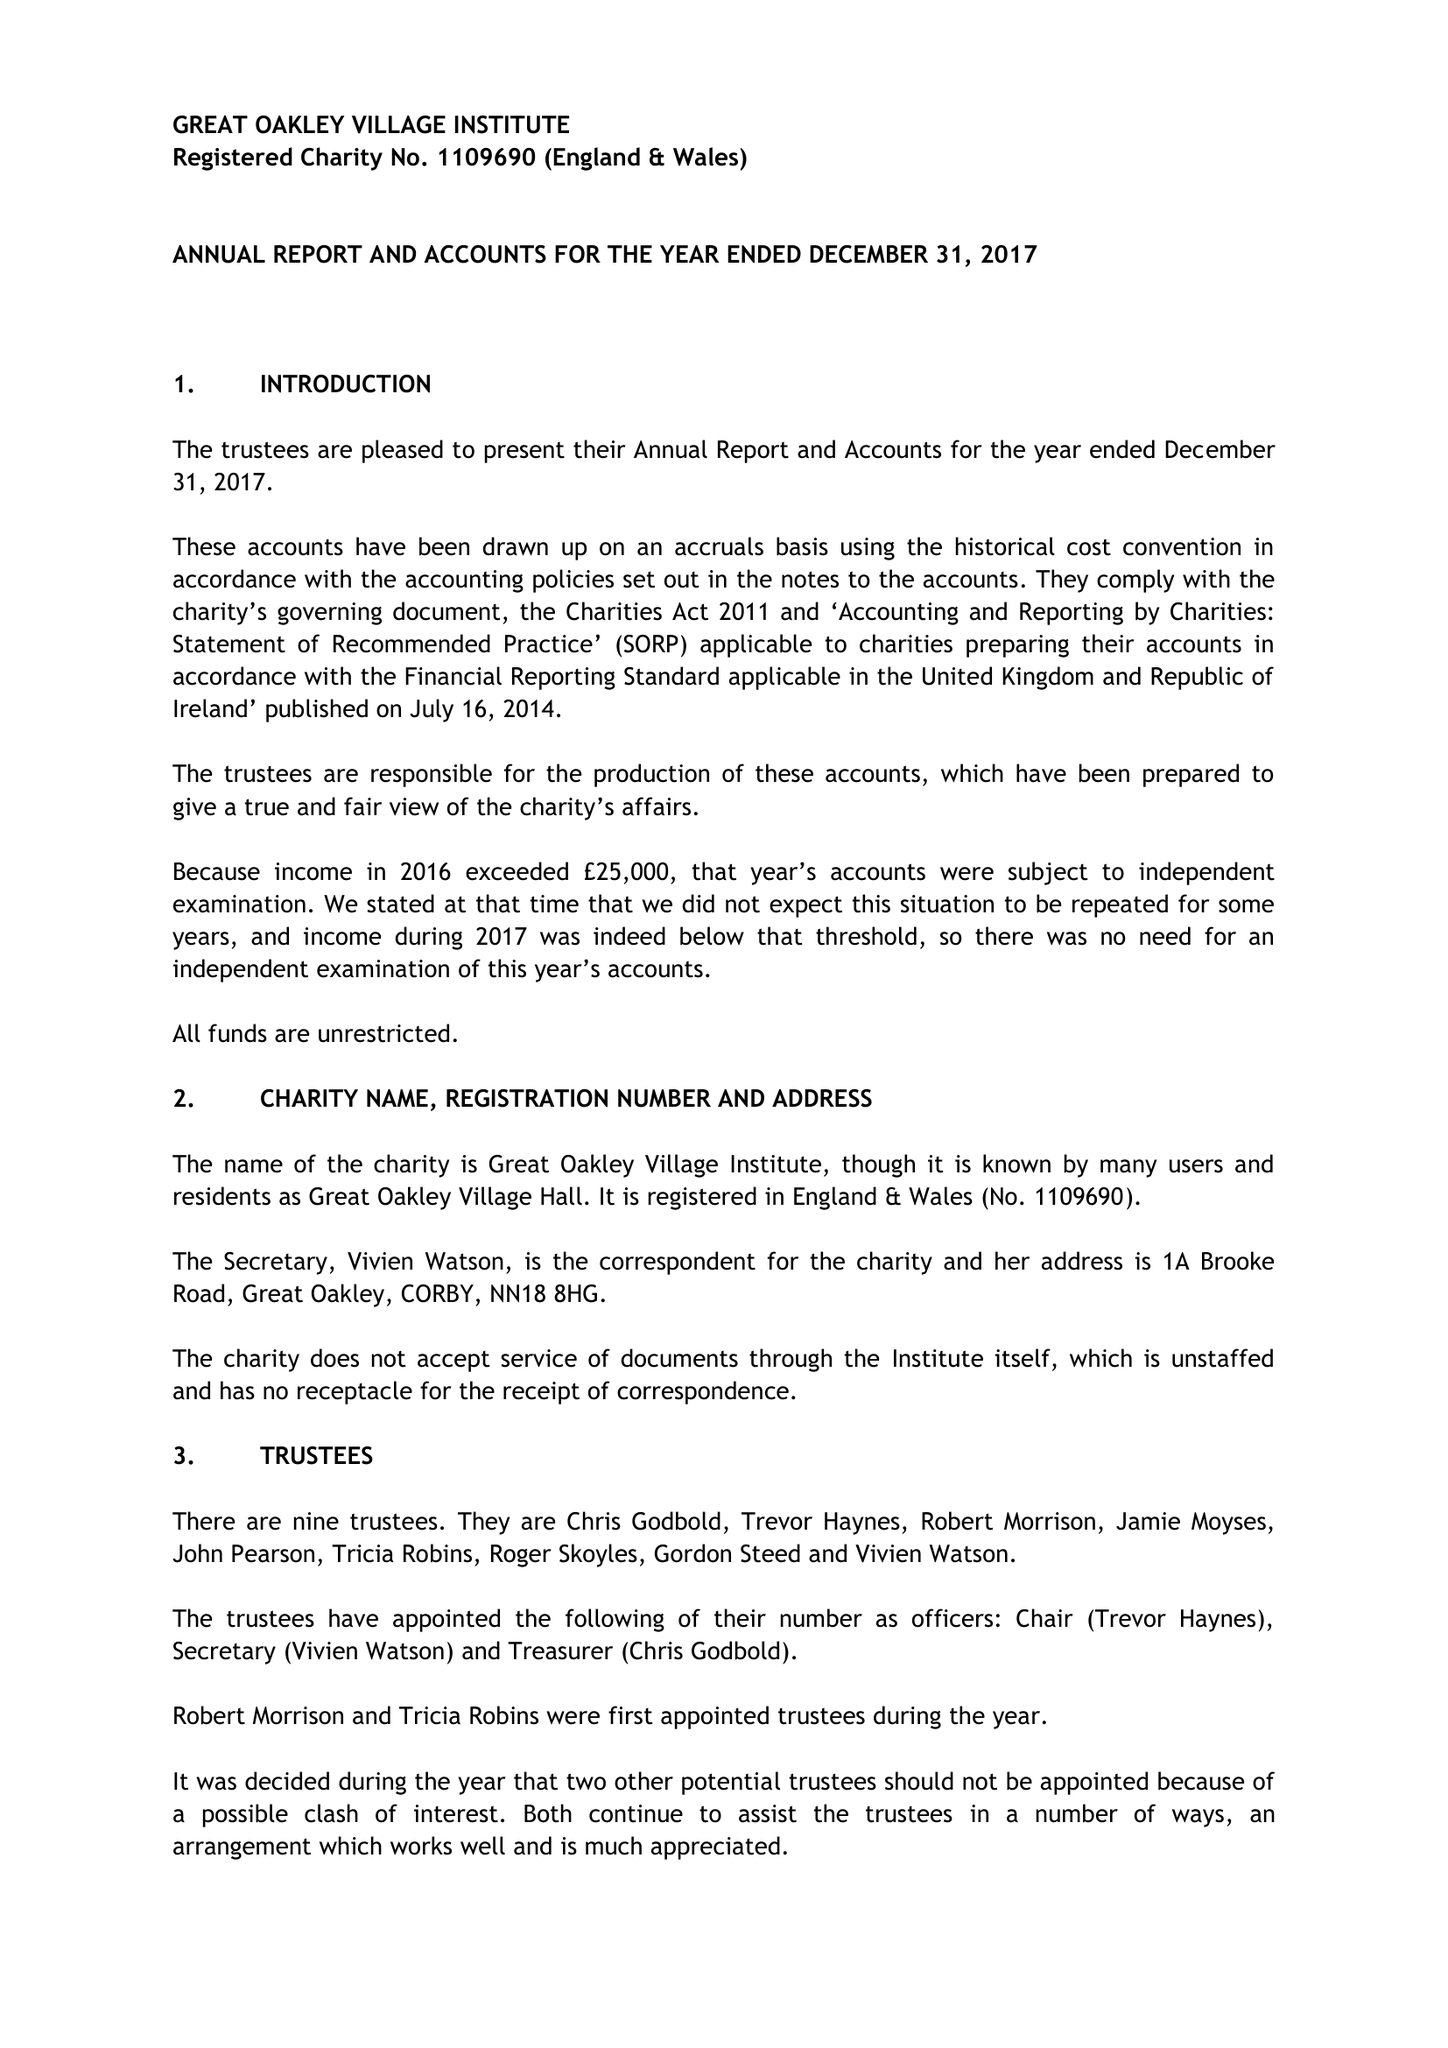What is the value for the spending_annually_in_british_pounds?
Answer the question using a single word or phrase. 18684.07 